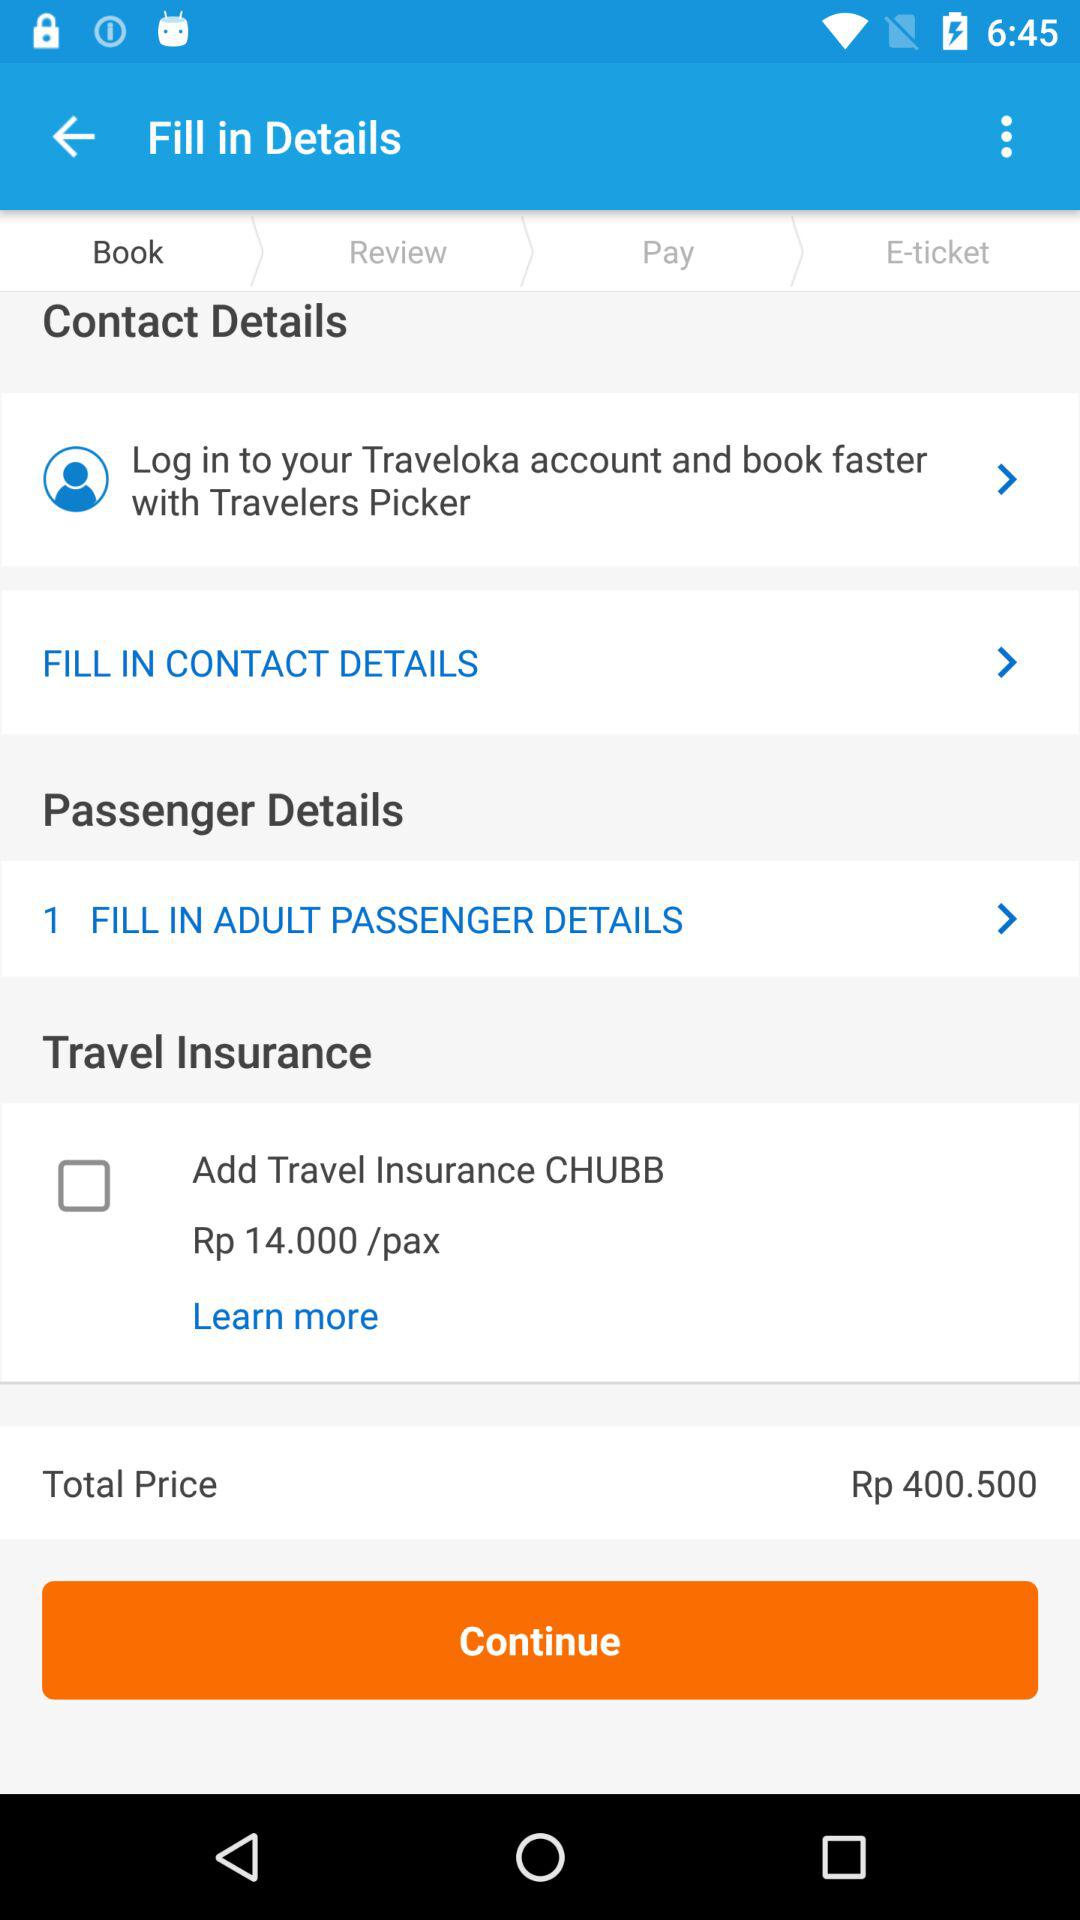Which tab is selected? The selected tab is Book. 